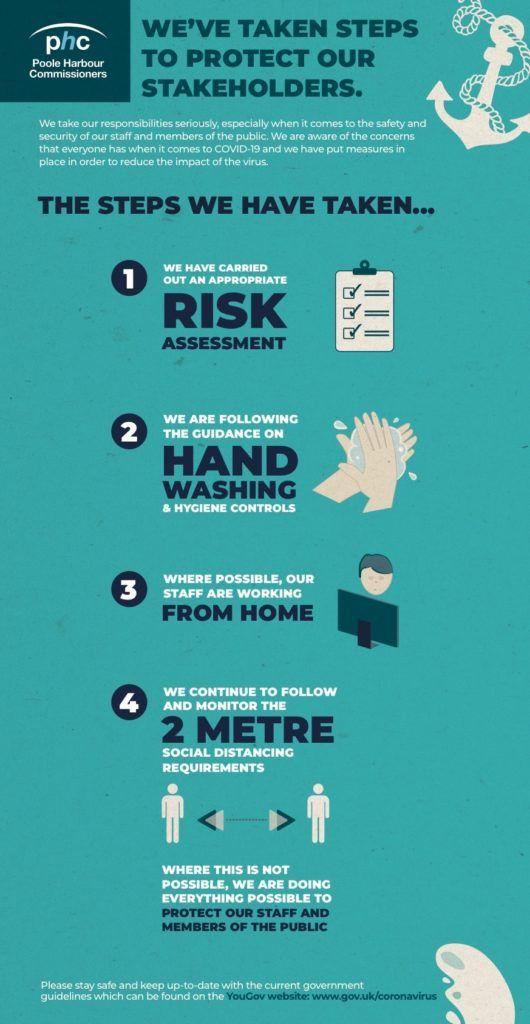Mention a couple of crucial points in this snapshot. In the process of protecting their stakeholders, 'phc' took 4 steps. Phc took measures to protect its stakeholders to mitigate the impact of the virus. 